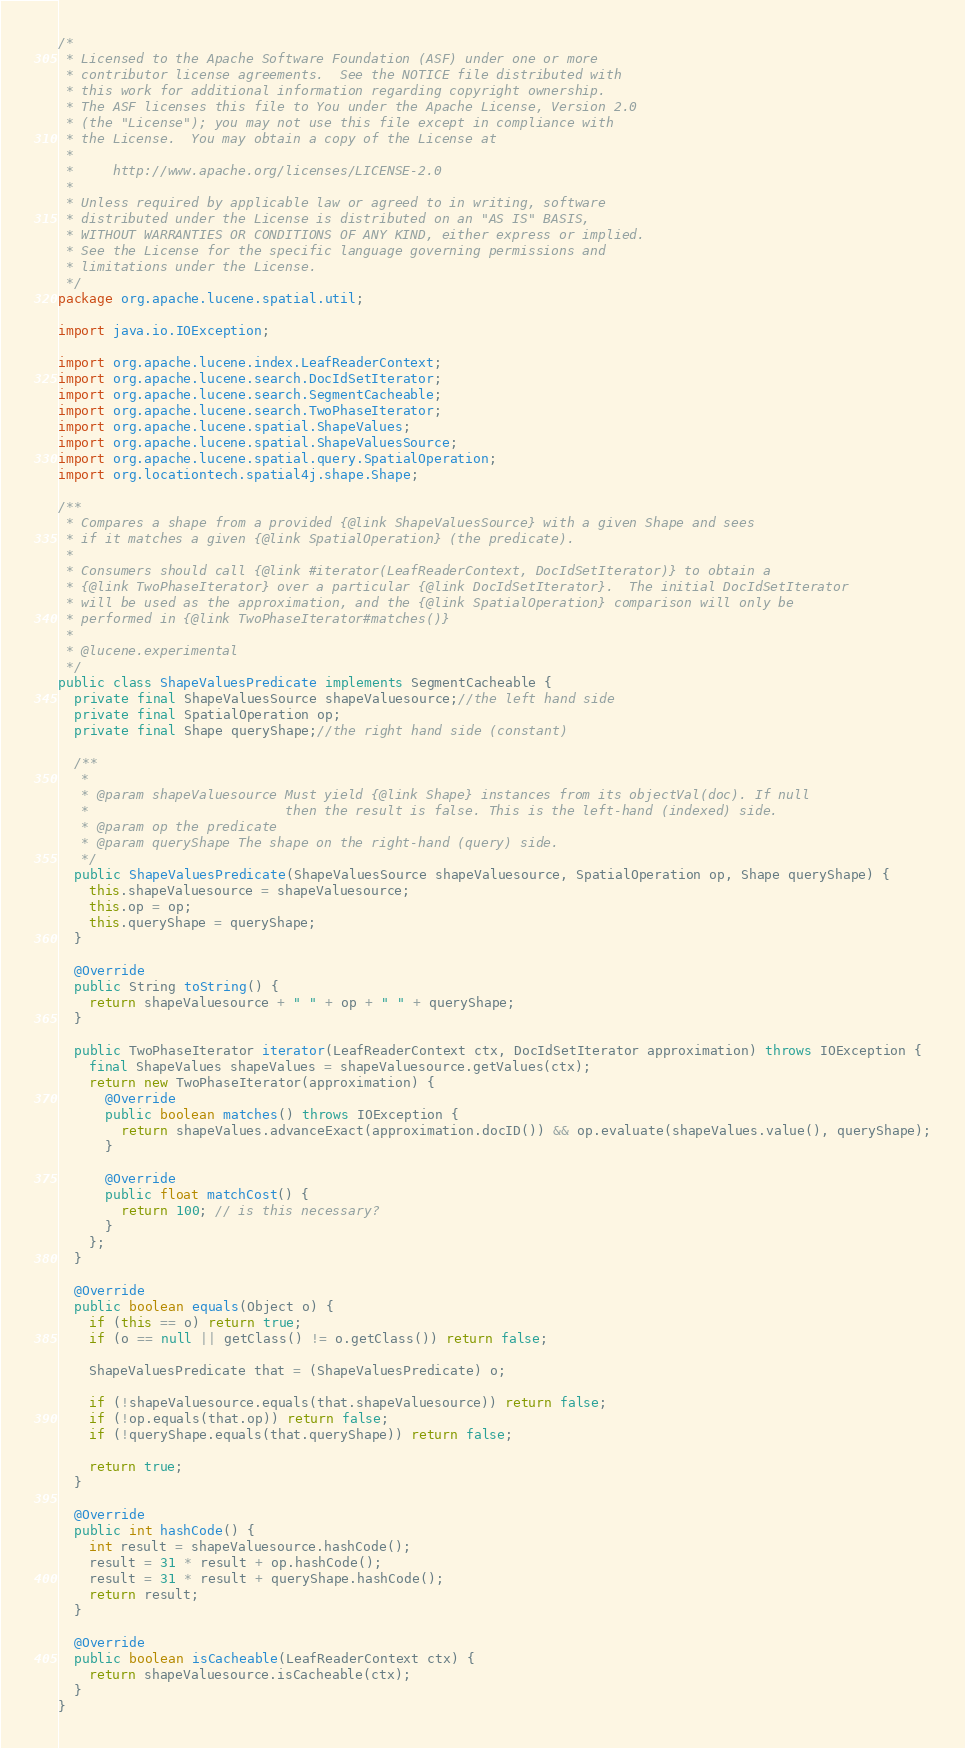<code> <loc_0><loc_0><loc_500><loc_500><_Java_>/*
 * Licensed to the Apache Software Foundation (ASF) under one or more
 * contributor license agreements.  See the NOTICE file distributed with
 * this work for additional information regarding copyright ownership.
 * The ASF licenses this file to You under the Apache License, Version 2.0
 * (the "License"); you may not use this file except in compliance with
 * the License.  You may obtain a copy of the License at
 *
 *     http://www.apache.org/licenses/LICENSE-2.0
 *
 * Unless required by applicable law or agreed to in writing, software
 * distributed under the License is distributed on an "AS IS" BASIS,
 * WITHOUT WARRANTIES OR CONDITIONS OF ANY KIND, either express or implied.
 * See the License for the specific language governing permissions and
 * limitations under the License.
 */
package org.apache.lucene.spatial.util;

import java.io.IOException;

import org.apache.lucene.index.LeafReaderContext;
import org.apache.lucene.search.DocIdSetIterator;
import org.apache.lucene.search.SegmentCacheable;
import org.apache.lucene.search.TwoPhaseIterator;
import org.apache.lucene.spatial.ShapeValues;
import org.apache.lucene.spatial.ShapeValuesSource;
import org.apache.lucene.spatial.query.SpatialOperation;
import org.locationtech.spatial4j.shape.Shape;

/**
 * Compares a shape from a provided {@link ShapeValuesSource} with a given Shape and sees
 * if it matches a given {@link SpatialOperation} (the predicate).
 *
 * Consumers should call {@link #iterator(LeafReaderContext, DocIdSetIterator)} to obtain a
 * {@link TwoPhaseIterator} over a particular {@link DocIdSetIterator}.  The initial DocIdSetIterator
 * will be used as the approximation, and the {@link SpatialOperation} comparison will only be
 * performed in {@link TwoPhaseIterator#matches()}
 *
 * @lucene.experimental
 */
public class ShapeValuesPredicate implements SegmentCacheable {
  private final ShapeValuesSource shapeValuesource;//the left hand side
  private final SpatialOperation op;
  private final Shape queryShape;//the right hand side (constant)

  /**
   *
   * @param shapeValuesource Must yield {@link Shape} instances from its objectVal(doc). If null
   *                         then the result is false. This is the left-hand (indexed) side.
   * @param op the predicate
   * @param queryShape The shape on the right-hand (query) side.
   */
  public ShapeValuesPredicate(ShapeValuesSource shapeValuesource, SpatialOperation op, Shape queryShape) {
    this.shapeValuesource = shapeValuesource;
    this.op = op;
    this.queryShape = queryShape;
  }

  @Override
  public String toString() {
    return shapeValuesource + " " + op + " " + queryShape;
  }

  public TwoPhaseIterator iterator(LeafReaderContext ctx, DocIdSetIterator approximation) throws IOException {
    final ShapeValues shapeValues = shapeValuesource.getValues(ctx);
    return new TwoPhaseIterator(approximation) {
      @Override
      public boolean matches() throws IOException {
        return shapeValues.advanceExact(approximation.docID()) && op.evaluate(shapeValues.value(), queryShape);
      }

      @Override
      public float matchCost() {
        return 100; // is this necessary?
      }
    };
  }

  @Override
  public boolean equals(Object o) {
    if (this == o) return true;
    if (o == null || getClass() != o.getClass()) return false;

    ShapeValuesPredicate that = (ShapeValuesPredicate) o;

    if (!shapeValuesource.equals(that.shapeValuesource)) return false;
    if (!op.equals(that.op)) return false;
    if (!queryShape.equals(that.queryShape)) return false;

    return true;
  }

  @Override
  public int hashCode() {
    int result = shapeValuesource.hashCode();
    result = 31 * result + op.hashCode();
    result = 31 * result + queryShape.hashCode();
    return result;
  }

  @Override
  public boolean isCacheable(LeafReaderContext ctx) {
    return shapeValuesource.isCacheable(ctx);
  }
}
</code> 